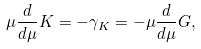Convert formula to latex. <formula><loc_0><loc_0><loc_500><loc_500>\mu \frac { d } { d \mu } K = - \gamma _ { K } = - \mu \frac { d } { d \mu } G ,</formula> 